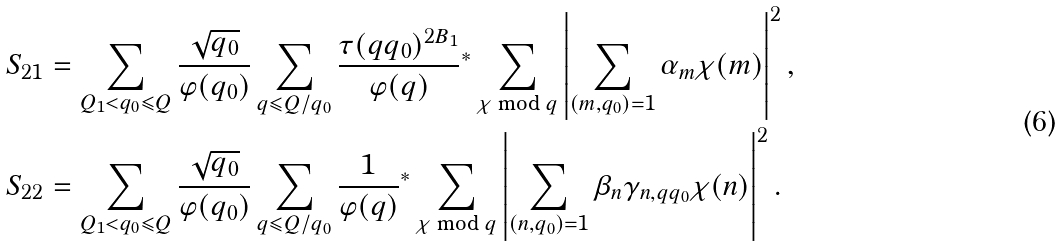Convert formula to latex. <formula><loc_0><loc_0><loc_500><loc_500>S _ { 2 1 } & = \sum _ { Q _ { 1 } < q _ { 0 } \leqslant Q } \frac { \sqrt { q _ { 0 } } } { \varphi ( q _ { 0 } ) } \sum _ { q \leqslant Q / q _ { 0 } } \frac { \tau ( q q _ { 0 } ) ^ { 2 B _ { 1 } } } { \varphi ( q ) } { ^ { * } } \sum _ { \chi \bmod q } \left | \sum _ { ( m , q _ { 0 } ) = 1 } \alpha _ { m } \chi ( m ) \right | ^ { 2 } , \\ S _ { 2 2 } & = \sum _ { Q _ { 1 } < q _ { 0 } \leqslant Q } \frac { \sqrt { q _ { 0 } } } { \varphi ( q _ { 0 } ) } \sum _ { q \leqslant Q / q _ { 0 } } \frac { 1 } { \varphi ( q ) } { ^ { * } } \sum _ { \chi \bmod q } \left | \sum _ { ( n , q _ { 0 } ) = 1 } \beta _ { n } \gamma _ { n , q q _ { 0 } } \chi ( n ) \right | ^ { 2 } .</formula> 